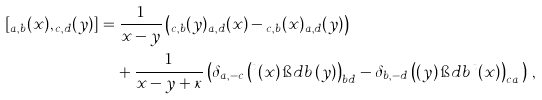<formula> <loc_0><loc_0><loc_500><loc_500>[ \L _ { a , b } ( x ) , \L _ { c , d } ( y ) ] & = \frac { 1 } { x - y } \left ( \L _ { c , b } ( y ) \L _ { a , d } ( x ) - \L _ { c , b } ( x ) \L _ { a , d } ( y ) \right ) \\ & \quad + \frac { 1 } { x - y + \kappa } \left ( \delta _ { a , - c } \left ( \L ^ { t } ( x ) \, \i d b \, \L ( y ) \right ) _ { b d } - \delta _ { b , - d } \left ( \L ( y ) \, \i d b \, \L ^ { t } ( x ) \right ) _ { c a } \, \right ) \, ,</formula> 